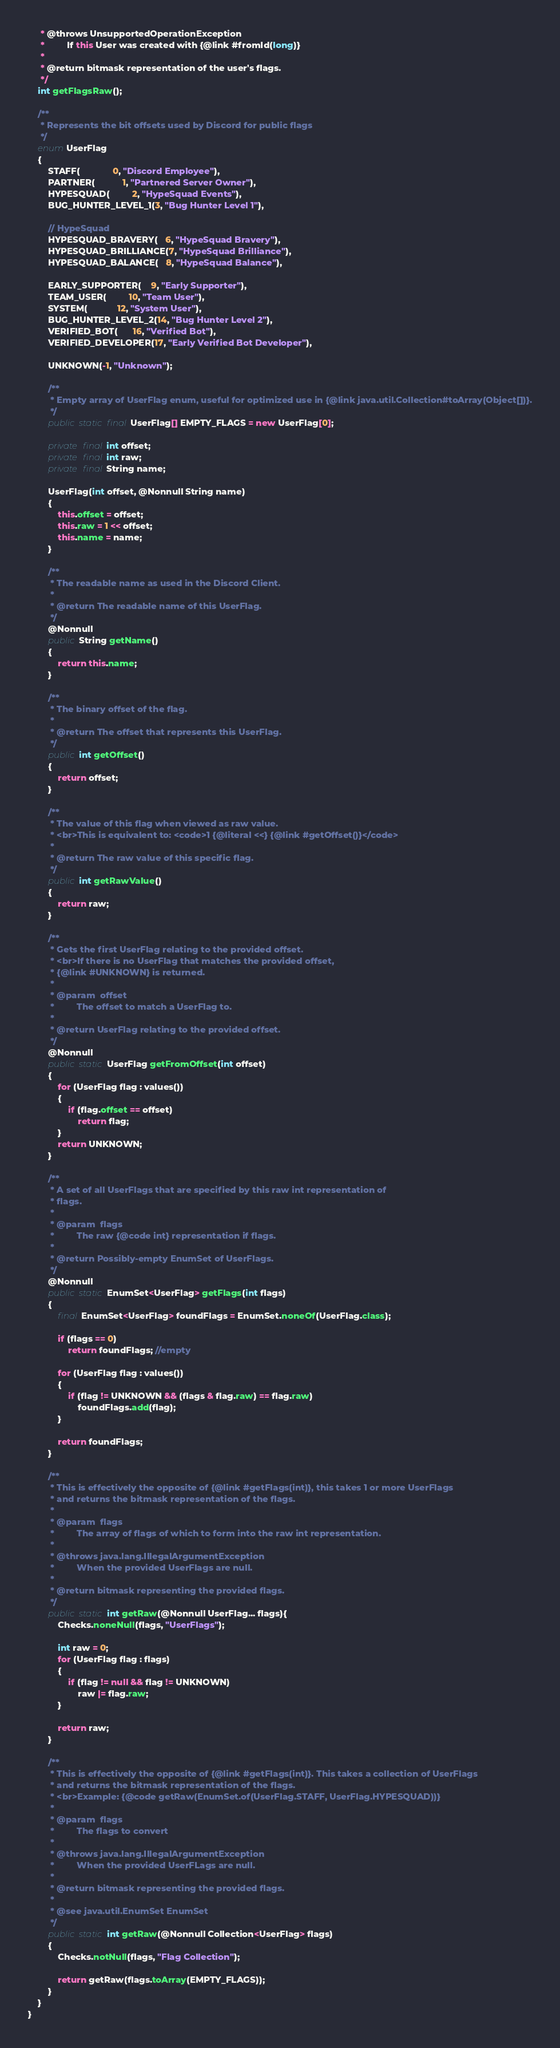<code> <loc_0><loc_0><loc_500><loc_500><_Java_>     * @throws UnsupportedOperationException
     *         If this User was created with {@link #fromId(long)}
     * 
     * @return bitmask representation of the user's flags.
     */
    int getFlagsRaw();

    /**
     * Represents the bit offsets used by Discord for public flags
     */
    enum UserFlag
    {
        STAFF(             0, "Discord Employee"),
        PARTNER(           1, "Partnered Server Owner"),
        HYPESQUAD(         2, "HypeSquad Events"),
        BUG_HUNTER_LEVEL_1(3, "Bug Hunter Level 1"),

        // HypeSquad
        HYPESQUAD_BRAVERY(   6, "HypeSquad Bravery"),
        HYPESQUAD_BRILLIANCE(7, "HypeSquad Brilliance"),
        HYPESQUAD_BALANCE(   8, "HypeSquad Balance"),

        EARLY_SUPPORTER(    9, "Early Supporter"),
        TEAM_USER(         10, "Team User"),
        SYSTEM(            12, "System User"),
        BUG_HUNTER_LEVEL_2(14, "Bug Hunter Level 2"),
        VERIFIED_BOT(      16, "Verified Bot"),
        VERIFIED_DEVELOPER(17, "Early Verified Bot Developer"),
        
        UNKNOWN(-1, "Unknown");

        /**
         * Empty array of UserFlag enum, useful for optimized use in {@link java.util.Collection#toArray(Object[])}.
         */
        public static final UserFlag[] EMPTY_FLAGS = new UserFlag[0];
        
        private final int offset;
        private final int raw;
        private final String name;

        UserFlag(int offset, @Nonnull String name)
        {
            this.offset = offset;
            this.raw = 1 << offset;
            this.name = name;
        }

        /**
         * The readable name as used in the Discord Client.
         * 
         * @return The readable name of this UserFlag.
         */
        @Nonnull
        public String getName()
        {
            return this.name;
        }

        /**
         * The binary offset of the flag.
         * 
         * @return The offset that represents this UserFlag.
         */
        public int getOffset()
        {
            return offset;
        }

        /**
         * The value of this flag when viewed as raw value.
         * <br>This is equivalent to: <code>1 {@literal <<} {@link #getOffset()}</code>
         * 
         * @return The raw value of this specific flag.
         */
        public int getRawValue()
        {
            return raw;
        }

        /**
         * Gets the first UserFlag relating to the provided offset.
         * <br>If there is no UserFlag that matches the provided offset,
         * {@link #UNKNOWN} is returned.
         * 
         * @param  offset
         *         The offset to match a UserFlag to.
         *         
         * @return UserFlag relating to the provided offset.
         */
        @Nonnull
        public static UserFlag getFromOffset(int offset)
        {
            for (UserFlag flag : values())
            {
                if (flag.offset == offset)
                    return flag;
            }
            return UNKNOWN;
        }
        
        /**
         * A set of all UserFlags that are specified by this raw int representation of
         * flags.
         * 
         * @param  flags
         *         The raw {@code int} representation if flags.
         *         
         * @return Possibly-empty EnumSet of UserFlags.
         */
        @Nonnull
        public static EnumSet<UserFlag> getFlags(int flags)
        {
            final EnumSet<UserFlag> foundFlags = EnumSet.noneOf(UserFlag.class);
            
            if (flags == 0)
                return foundFlags; //empty
            
            for (UserFlag flag : values())
            {
                if (flag != UNKNOWN && (flags & flag.raw) == flag.raw)
                    foundFlags.add(flag);
            }
                    
            return foundFlags;
        }

        /**
         * This is effectively the opposite of {@link #getFlags(int)}, this takes 1 or more UserFlags
         * and returns the bitmask representation of the flags.
         * 
         * @param  flags
         *         The array of flags of which to form into the raw int representation.
         *
         * @throws java.lang.IllegalArgumentException
         *         When the provided UserFlags are null.
         *         
         * @return bitmask representing the provided flags.
         */
        public static int getRaw(@Nonnull UserFlag... flags){
            Checks.noneNull(flags, "UserFlags");
            
            int raw = 0;
            for (UserFlag flag : flags)
            {
                if (flag != null && flag != UNKNOWN)
                    raw |= flag.raw;
            }
            
            return raw;
        }

        /**
         * This is effectively the opposite of {@link #getFlags(int)}. This takes a collection of UserFlags
         * and returns the bitmask representation of the flags.
         * <br>Example: {@code getRaw(EnumSet.of(UserFlag.STAFF, UserFlag.HYPESQUAD))}
         *
         * @param  flags
         *         The flags to convert
         *
         * @throws java.lang.IllegalArgumentException
         *         When the provided UserFLags are null.
         *
         * @return bitmask representing the provided flags.
         * 
         * @see java.util.EnumSet EnumSet
         */
        public static int getRaw(@Nonnull Collection<UserFlag> flags)
        {
            Checks.notNull(flags, "Flag Collection");
            
            return getRaw(flags.toArray(EMPTY_FLAGS));
        }
    }
}
</code> 